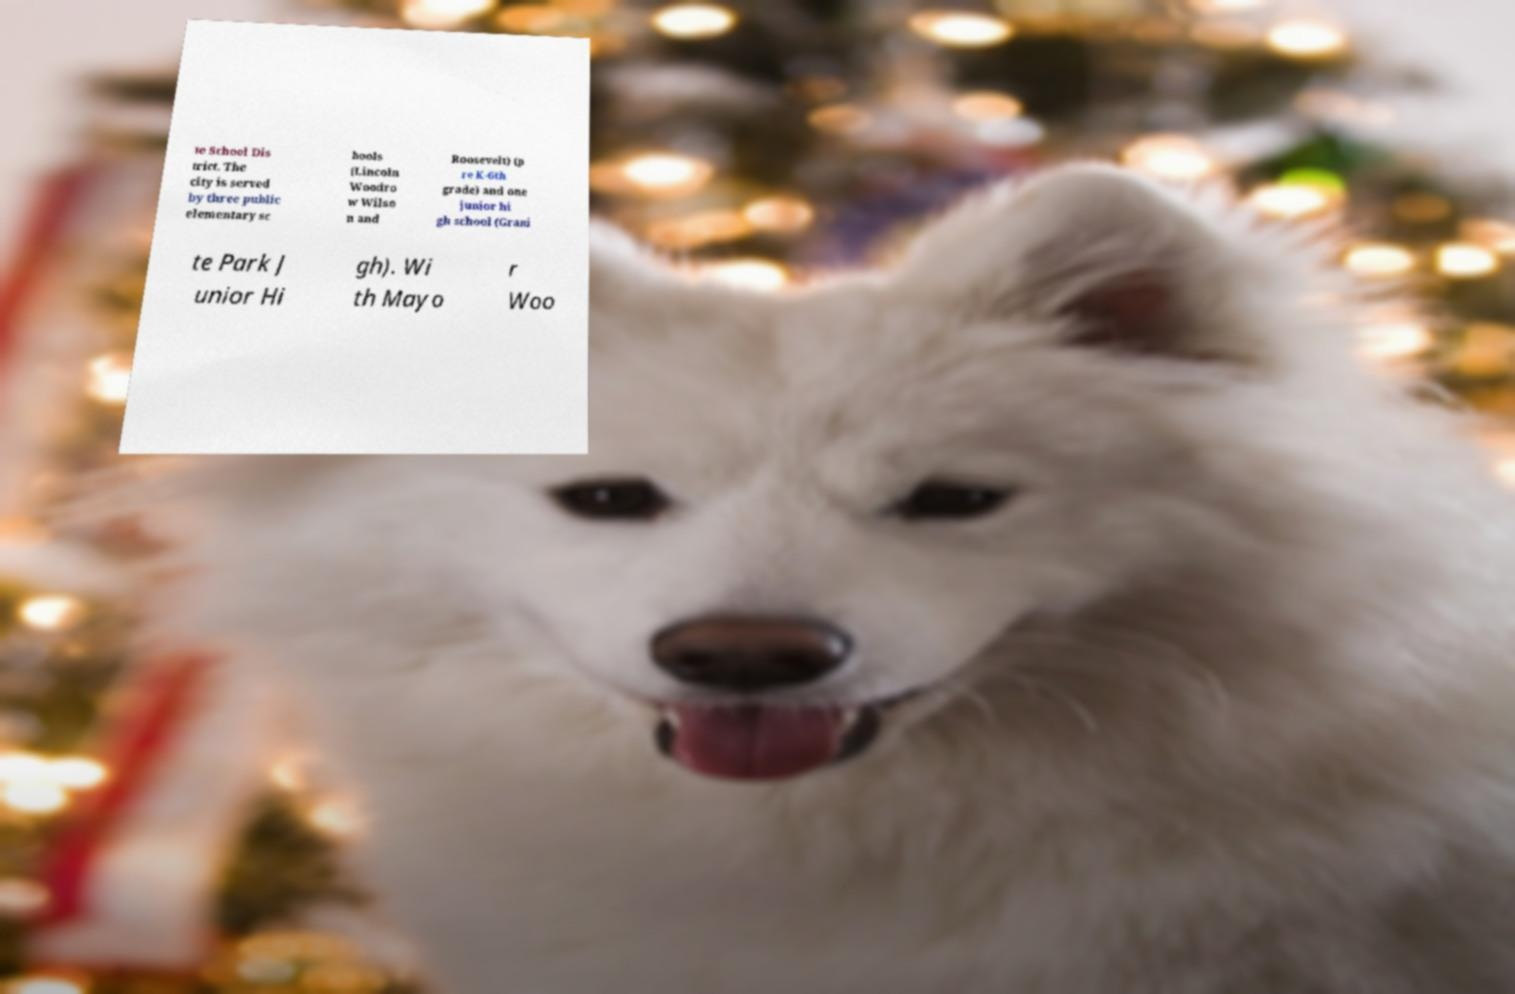Please identify and transcribe the text found in this image. te School Dis trict. The city is served by three public elementary sc hools (Lincoln Woodro w Wilso n and Roosevelt) (p re K-6th grade) and one junior hi gh school (Grani te Park J unior Hi gh). Wi th Mayo r Woo 